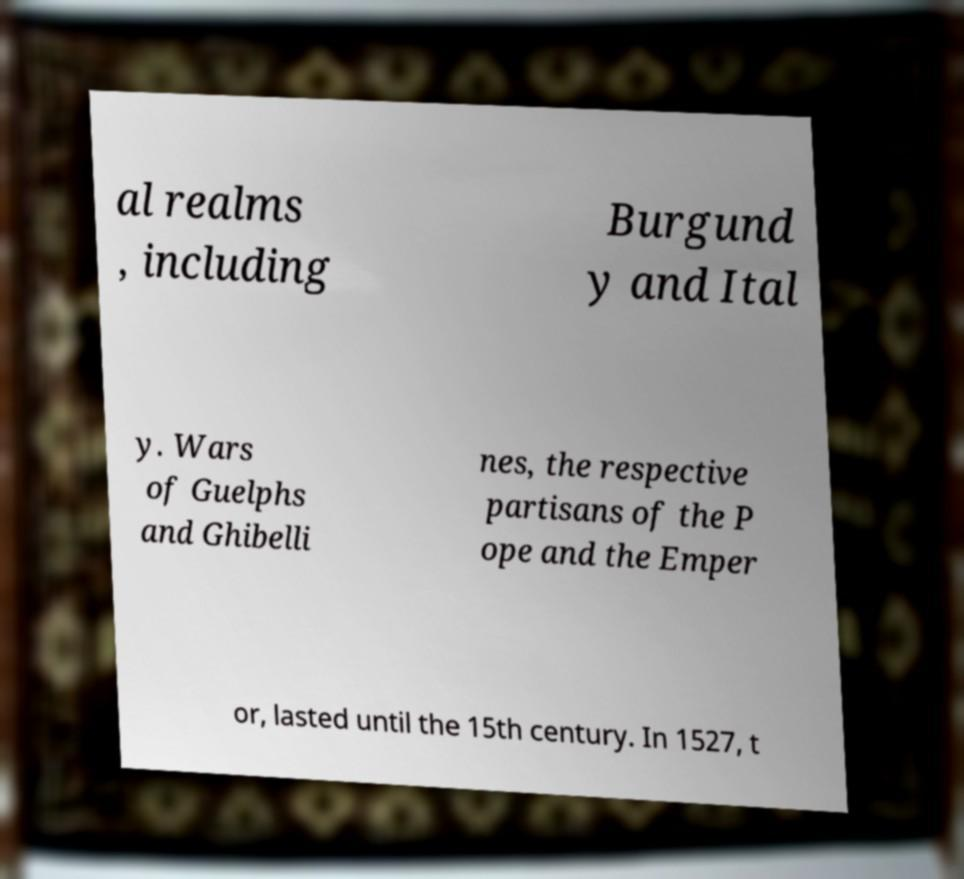What messages or text are displayed in this image? I need them in a readable, typed format. al realms , including Burgund y and Ital y. Wars of Guelphs and Ghibelli nes, the respective partisans of the P ope and the Emper or, lasted until the 15th century. In 1527, t 